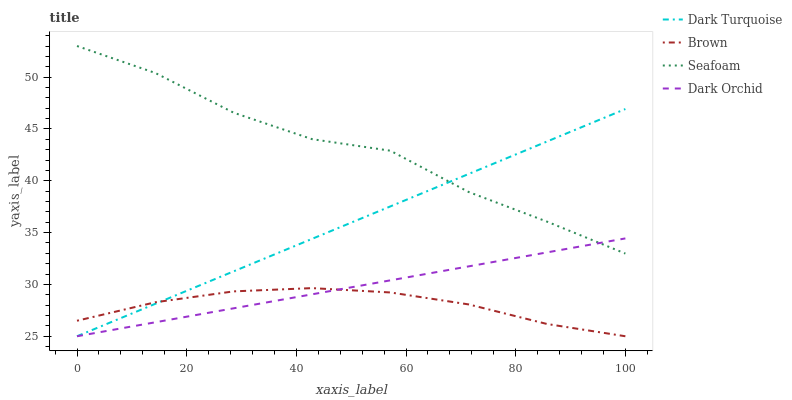Does Brown have the minimum area under the curve?
Answer yes or no. Yes. Does Seafoam have the maximum area under the curve?
Answer yes or no. Yes. Does Dark Orchid have the minimum area under the curve?
Answer yes or no. No. Does Dark Orchid have the maximum area under the curve?
Answer yes or no. No. Is Dark Orchid the smoothest?
Answer yes or no. Yes. Is Seafoam the roughest?
Answer yes or no. Yes. Is Seafoam the smoothest?
Answer yes or no. No. Is Dark Orchid the roughest?
Answer yes or no. No. Does Dark Turquoise have the lowest value?
Answer yes or no. Yes. Does Seafoam have the lowest value?
Answer yes or no. No. Does Seafoam have the highest value?
Answer yes or no. Yes. Does Dark Orchid have the highest value?
Answer yes or no. No. Is Brown less than Seafoam?
Answer yes or no. Yes. Is Seafoam greater than Brown?
Answer yes or no. Yes. Does Dark Turquoise intersect Brown?
Answer yes or no. Yes. Is Dark Turquoise less than Brown?
Answer yes or no. No. Is Dark Turquoise greater than Brown?
Answer yes or no. No. Does Brown intersect Seafoam?
Answer yes or no. No. 